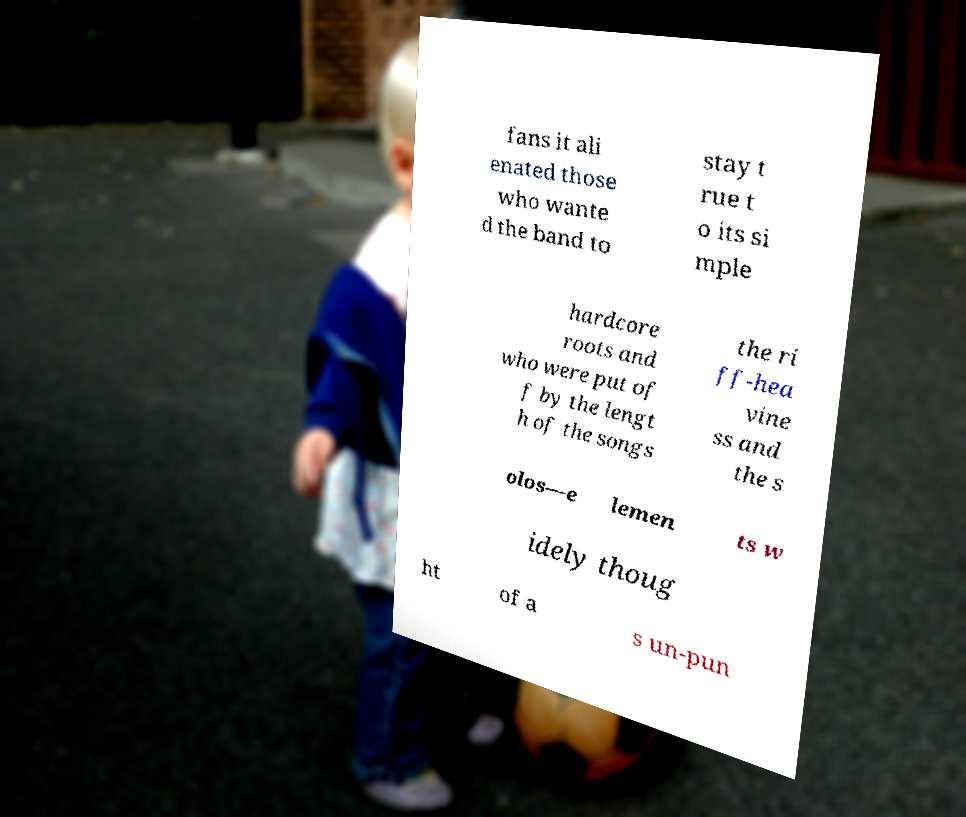There's text embedded in this image that I need extracted. Can you transcribe it verbatim? fans it ali enated those who wante d the band to stay t rue t o its si mple hardcore roots and who were put of f by the lengt h of the songs the ri ff-hea vine ss and the s olos—e lemen ts w idely thoug ht of a s un-pun 